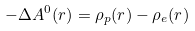<formula> <loc_0><loc_0><loc_500><loc_500>- \Delta A ^ { 0 } ( { r } ) = \rho _ { p } ( { r } ) - \rho _ { e } ( { r } )</formula> 